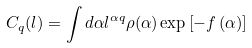Convert formula to latex. <formula><loc_0><loc_0><loc_500><loc_500>C _ { q } ( l ) = \int d \alpha l ^ { \alpha q } \rho ( \alpha ) \exp \left [ - f \left ( \alpha \right ) \right ]</formula> 